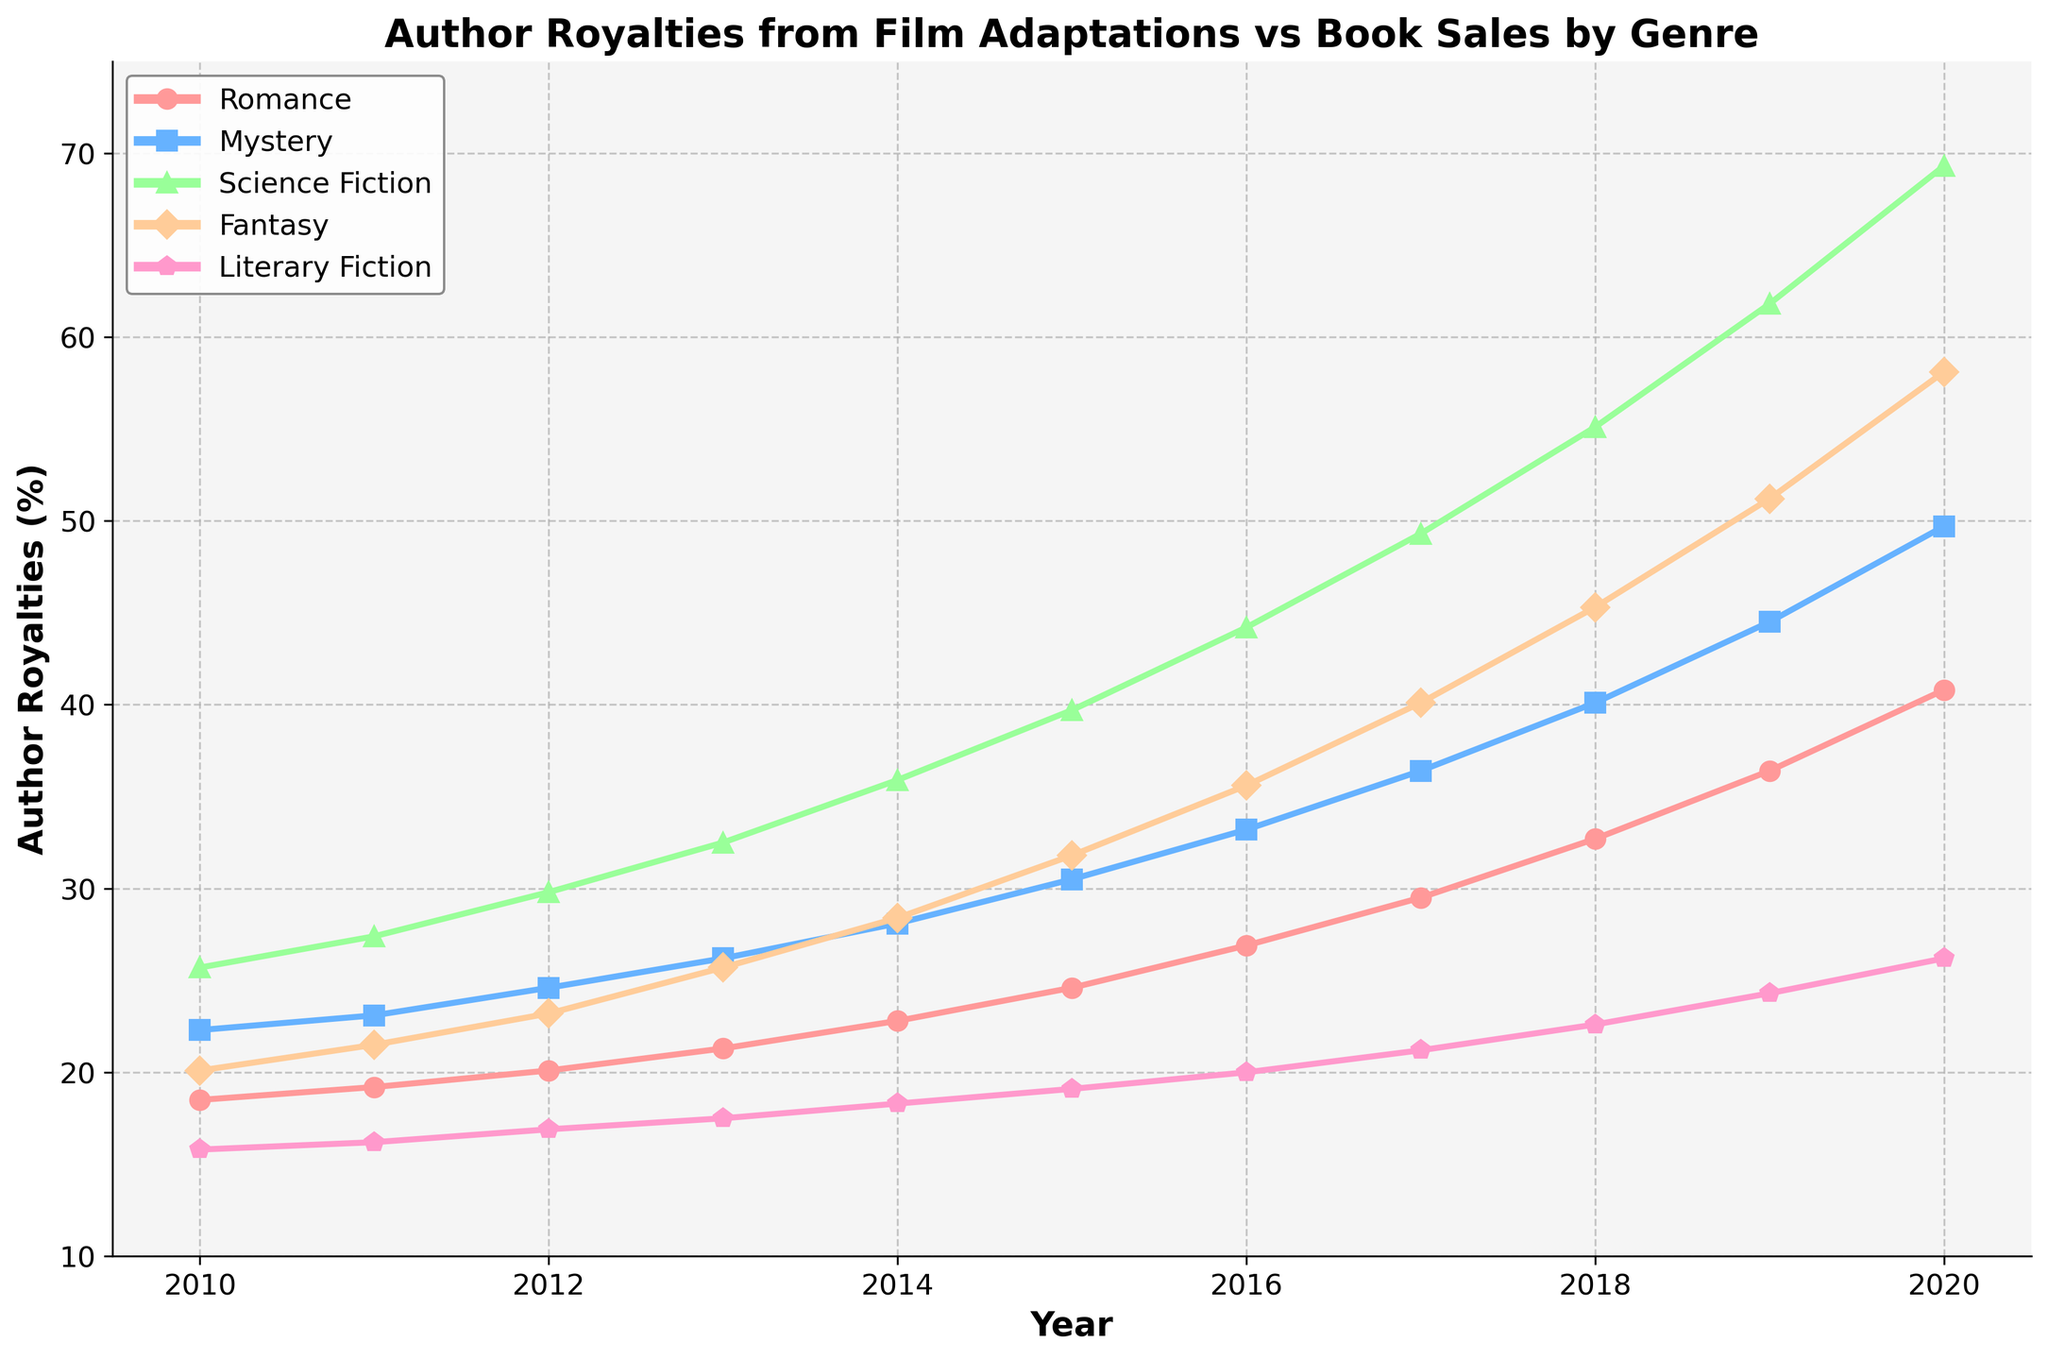Which genre had the highest increase in author royalties from 2010 to 2020? To find the genre with the highest increase, we need to subtract the royalty percentage of each genre in 2010 from its corresponding value in 2020. Romance: 40.8 - 18.5 = 22.3, Mystery: 49.7 - 22.3 = 27.4, Science Fiction: 69.3 - 25.7 = 43.6, Fantasy: 58.1 - 20.1 = 38.0, Literary Fiction: 26.2 - 15.8 = 10.4. Science Fiction has the highest increase.
Answer: Science Fiction What is the average annual royalty increase for the Romance genre from 2010 to 2020? First, calculate the total increase from 2010 to 2020: 40.8 - 18.5 = 22.3. Next, divide this increase by the number of years: 22.3 / 10 = 2.23. So the average annual increase is 2.23%.
Answer: 2.23% In comparison to the Fantasy genre, was the growth rate in royalties for Literary Fiction higher or lower? To compare the growth rates, we need to calculate the percentage increases: Fantasy: (58.1 - 20.1)/20.1 * 100 = 188.06%, Literary Fiction: (26.2 - 15.8)/15.8 * 100 = 65.82%. The growth rate for Literary Fiction is lower than for Fantasy.
Answer: Lower Which genre has consistently showing linear trends in author royalties over time? By visually inspecting the figure, we can observe how linear or consistent the trend line is. Romance and Literary Fiction exhibit the most linear trends compared to others which show more noticeable curvature.
Answer: Romance, Literary Fiction During which years did the Mystery genre experience a sharp increase in royalties? By visually inspecting the line chart, noticeable jumps in royalties for the Mystery genre occur primarily between 2014-2015 and 2017-2018.
Answer: 2014-2015, 2017-2018 Comparing the royalties of Science Fiction in 2012 and Romance in 2017, which is higher? Refer to the y-axis values for 2012 Science Fiction and 2017 Romance. Science Fiction in 2012 is at 29.8%, while Romance in 2017 is at 29.5%. Thus, Science Fiction in 2012 has a higher royalty percentage.
Answer: Science Fiction in 2012 If we sum up the royalties of all genres in 2020, what is the total percentage? Adding the values for all genres in 2020: 40.8 (Romance) + 49.7 (Mystery) + 69.3 (Science Fiction) + 58.1 (Fantasy) + 26.2 (Literary Fiction). This yields a total of 244.1%.
Answer: 244.1% 